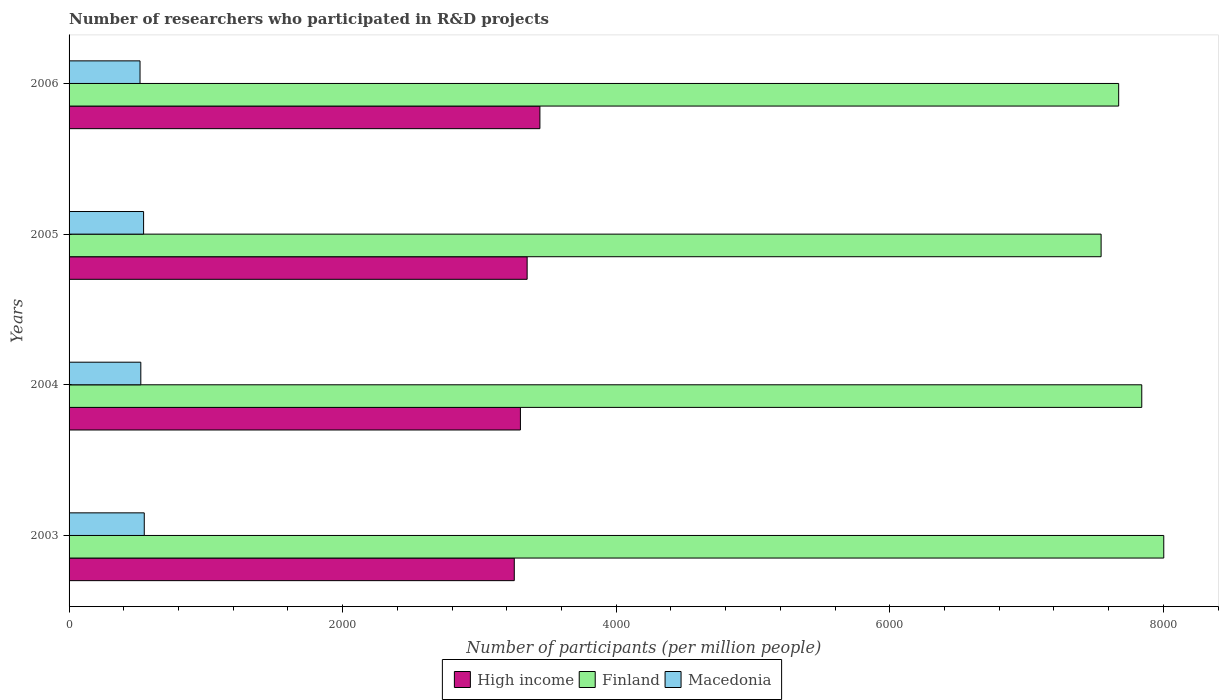How many different coloured bars are there?
Your response must be concise. 3. Are the number of bars per tick equal to the number of legend labels?
Keep it short and to the point. Yes. How many bars are there on the 4th tick from the top?
Make the answer very short. 3. How many bars are there on the 2nd tick from the bottom?
Offer a terse response. 3. What is the number of researchers who participated in R&D projects in High income in 2005?
Ensure brevity in your answer.  3348.65. Across all years, what is the maximum number of researchers who participated in R&D projects in Macedonia?
Your response must be concise. 549.66. Across all years, what is the minimum number of researchers who participated in R&D projects in High income?
Offer a very short reply. 3254.64. What is the total number of researchers who participated in R&D projects in Finland in the graph?
Your response must be concise. 3.11e+04. What is the difference between the number of researchers who participated in R&D projects in Finland in 2003 and that in 2006?
Give a very brief answer. 329.55. What is the difference between the number of researchers who participated in R&D projects in High income in 2004 and the number of researchers who participated in R&D projects in Macedonia in 2003?
Your response must be concise. 2749.95. What is the average number of researchers who participated in R&D projects in Finland per year?
Your response must be concise. 7765.53. In the year 2005, what is the difference between the number of researchers who participated in R&D projects in High income and number of researchers who participated in R&D projects in Finland?
Provide a succinct answer. -4195.99. In how many years, is the number of researchers who participated in R&D projects in Macedonia greater than 1200 ?
Keep it short and to the point. 0. What is the ratio of the number of researchers who participated in R&D projects in High income in 2005 to that in 2006?
Your answer should be compact. 0.97. Is the number of researchers who participated in R&D projects in Macedonia in 2005 less than that in 2006?
Offer a terse response. No. Is the difference between the number of researchers who participated in R&D projects in High income in 2004 and 2005 greater than the difference between the number of researchers who participated in R&D projects in Finland in 2004 and 2005?
Ensure brevity in your answer.  No. What is the difference between the highest and the second highest number of researchers who participated in R&D projects in Finland?
Ensure brevity in your answer.  160.81. What is the difference between the highest and the lowest number of researchers who participated in R&D projects in High income?
Your answer should be very brief. 187.39. Is the sum of the number of researchers who participated in R&D projects in High income in 2003 and 2005 greater than the maximum number of researchers who participated in R&D projects in Finland across all years?
Give a very brief answer. No. What does the 1st bar from the top in 2004 represents?
Offer a terse response. Macedonia. What does the 1st bar from the bottom in 2006 represents?
Make the answer very short. High income. How many bars are there?
Ensure brevity in your answer.  12. How many years are there in the graph?
Ensure brevity in your answer.  4. Does the graph contain grids?
Your answer should be very brief. No. Where does the legend appear in the graph?
Give a very brief answer. Bottom center. How many legend labels are there?
Ensure brevity in your answer.  3. What is the title of the graph?
Your answer should be compact. Number of researchers who participated in R&D projects. Does "Norway" appear as one of the legend labels in the graph?
Make the answer very short. No. What is the label or title of the X-axis?
Your answer should be compact. Number of participants (per million people). What is the Number of participants (per million people) of High income in 2003?
Your response must be concise. 3254.64. What is the Number of participants (per million people) in Finland in 2003?
Your answer should be very brief. 8002.61. What is the Number of participants (per million people) in Macedonia in 2003?
Ensure brevity in your answer.  549.66. What is the Number of participants (per million people) in High income in 2004?
Ensure brevity in your answer.  3299.61. What is the Number of participants (per million people) in Finland in 2004?
Provide a succinct answer. 7841.8. What is the Number of participants (per million people) in Macedonia in 2004?
Provide a short and direct response. 524.42. What is the Number of participants (per million people) of High income in 2005?
Your answer should be compact. 3348.65. What is the Number of participants (per million people) in Finland in 2005?
Offer a very short reply. 7544.65. What is the Number of participants (per million people) of Macedonia in 2005?
Your answer should be compact. 544.82. What is the Number of participants (per million people) of High income in 2006?
Give a very brief answer. 3442.03. What is the Number of participants (per million people) of Finland in 2006?
Offer a terse response. 7673.06. What is the Number of participants (per million people) in Macedonia in 2006?
Provide a succinct answer. 518.72. Across all years, what is the maximum Number of participants (per million people) in High income?
Make the answer very short. 3442.03. Across all years, what is the maximum Number of participants (per million people) in Finland?
Your answer should be compact. 8002.61. Across all years, what is the maximum Number of participants (per million people) in Macedonia?
Provide a short and direct response. 549.66. Across all years, what is the minimum Number of participants (per million people) in High income?
Offer a very short reply. 3254.64. Across all years, what is the minimum Number of participants (per million people) of Finland?
Your answer should be compact. 7544.65. Across all years, what is the minimum Number of participants (per million people) in Macedonia?
Give a very brief answer. 518.72. What is the total Number of participants (per million people) in High income in the graph?
Keep it short and to the point. 1.33e+04. What is the total Number of participants (per million people) of Finland in the graph?
Provide a short and direct response. 3.11e+04. What is the total Number of participants (per million people) of Macedonia in the graph?
Ensure brevity in your answer.  2137.62. What is the difference between the Number of participants (per million people) of High income in 2003 and that in 2004?
Your response must be concise. -44.97. What is the difference between the Number of participants (per million people) of Finland in 2003 and that in 2004?
Keep it short and to the point. 160.81. What is the difference between the Number of participants (per million people) of Macedonia in 2003 and that in 2004?
Ensure brevity in your answer.  25.24. What is the difference between the Number of participants (per million people) of High income in 2003 and that in 2005?
Your answer should be compact. -94.02. What is the difference between the Number of participants (per million people) of Finland in 2003 and that in 2005?
Give a very brief answer. 457.96. What is the difference between the Number of participants (per million people) of Macedonia in 2003 and that in 2005?
Offer a terse response. 4.85. What is the difference between the Number of participants (per million people) in High income in 2003 and that in 2006?
Ensure brevity in your answer.  -187.39. What is the difference between the Number of participants (per million people) in Finland in 2003 and that in 2006?
Offer a very short reply. 329.55. What is the difference between the Number of participants (per million people) of Macedonia in 2003 and that in 2006?
Ensure brevity in your answer.  30.94. What is the difference between the Number of participants (per million people) in High income in 2004 and that in 2005?
Keep it short and to the point. -49.04. What is the difference between the Number of participants (per million people) in Finland in 2004 and that in 2005?
Give a very brief answer. 297.15. What is the difference between the Number of participants (per million people) of Macedonia in 2004 and that in 2005?
Provide a succinct answer. -20.4. What is the difference between the Number of participants (per million people) of High income in 2004 and that in 2006?
Offer a very short reply. -142.42. What is the difference between the Number of participants (per million people) of Finland in 2004 and that in 2006?
Offer a terse response. 168.74. What is the difference between the Number of participants (per million people) of Macedonia in 2004 and that in 2006?
Make the answer very short. 5.7. What is the difference between the Number of participants (per million people) in High income in 2005 and that in 2006?
Your answer should be compact. -93.37. What is the difference between the Number of participants (per million people) in Finland in 2005 and that in 2006?
Keep it short and to the point. -128.41. What is the difference between the Number of participants (per million people) in Macedonia in 2005 and that in 2006?
Your response must be concise. 26.09. What is the difference between the Number of participants (per million people) in High income in 2003 and the Number of participants (per million people) in Finland in 2004?
Keep it short and to the point. -4587.16. What is the difference between the Number of participants (per million people) of High income in 2003 and the Number of participants (per million people) of Macedonia in 2004?
Provide a succinct answer. 2730.22. What is the difference between the Number of participants (per million people) in Finland in 2003 and the Number of participants (per million people) in Macedonia in 2004?
Make the answer very short. 7478.19. What is the difference between the Number of participants (per million people) of High income in 2003 and the Number of participants (per million people) of Finland in 2005?
Offer a terse response. -4290.01. What is the difference between the Number of participants (per million people) of High income in 2003 and the Number of participants (per million people) of Macedonia in 2005?
Your answer should be compact. 2709.82. What is the difference between the Number of participants (per million people) of Finland in 2003 and the Number of participants (per million people) of Macedonia in 2005?
Offer a very short reply. 7457.79. What is the difference between the Number of participants (per million people) of High income in 2003 and the Number of participants (per million people) of Finland in 2006?
Keep it short and to the point. -4418.42. What is the difference between the Number of participants (per million people) in High income in 2003 and the Number of participants (per million people) in Macedonia in 2006?
Your answer should be very brief. 2735.91. What is the difference between the Number of participants (per million people) of Finland in 2003 and the Number of participants (per million people) of Macedonia in 2006?
Your answer should be compact. 7483.88. What is the difference between the Number of participants (per million people) of High income in 2004 and the Number of participants (per million people) of Finland in 2005?
Make the answer very short. -4245.04. What is the difference between the Number of participants (per million people) in High income in 2004 and the Number of participants (per million people) in Macedonia in 2005?
Give a very brief answer. 2754.8. What is the difference between the Number of participants (per million people) of Finland in 2004 and the Number of participants (per million people) of Macedonia in 2005?
Give a very brief answer. 7296.98. What is the difference between the Number of participants (per million people) in High income in 2004 and the Number of participants (per million people) in Finland in 2006?
Your response must be concise. -4373.44. What is the difference between the Number of participants (per million people) of High income in 2004 and the Number of participants (per million people) of Macedonia in 2006?
Give a very brief answer. 2780.89. What is the difference between the Number of participants (per million people) of Finland in 2004 and the Number of participants (per million people) of Macedonia in 2006?
Give a very brief answer. 7323.07. What is the difference between the Number of participants (per million people) of High income in 2005 and the Number of participants (per million people) of Finland in 2006?
Your answer should be compact. -4324.4. What is the difference between the Number of participants (per million people) of High income in 2005 and the Number of participants (per million people) of Macedonia in 2006?
Provide a short and direct response. 2829.93. What is the difference between the Number of participants (per million people) in Finland in 2005 and the Number of participants (per million people) in Macedonia in 2006?
Provide a short and direct response. 7025.92. What is the average Number of participants (per million people) of High income per year?
Your answer should be compact. 3336.23. What is the average Number of participants (per million people) of Finland per year?
Provide a short and direct response. 7765.53. What is the average Number of participants (per million people) of Macedonia per year?
Ensure brevity in your answer.  534.41. In the year 2003, what is the difference between the Number of participants (per million people) in High income and Number of participants (per million people) in Finland?
Keep it short and to the point. -4747.97. In the year 2003, what is the difference between the Number of participants (per million people) in High income and Number of participants (per million people) in Macedonia?
Give a very brief answer. 2704.97. In the year 2003, what is the difference between the Number of participants (per million people) in Finland and Number of participants (per million people) in Macedonia?
Offer a terse response. 7452.95. In the year 2004, what is the difference between the Number of participants (per million people) of High income and Number of participants (per million people) of Finland?
Make the answer very short. -4542.19. In the year 2004, what is the difference between the Number of participants (per million people) of High income and Number of participants (per million people) of Macedonia?
Your answer should be compact. 2775.19. In the year 2004, what is the difference between the Number of participants (per million people) in Finland and Number of participants (per million people) in Macedonia?
Your answer should be very brief. 7317.38. In the year 2005, what is the difference between the Number of participants (per million people) of High income and Number of participants (per million people) of Finland?
Provide a short and direct response. -4195.99. In the year 2005, what is the difference between the Number of participants (per million people) of High income and Number of participants (per million people) of Macedonia?
Give a very brief answer. 2803.84. In the year 2005, what is the difference between the Number of participants (per million people) of Finland and Number of participants (per million people) of Macedonia?
Your answer should be compact. 6999.83. In the year 2006, what is the difference between the Number of participants (per million people) of High income and Number of participants (per million people) of Finland?
Offer a very short reply. -4231.03. In the year 2006, what is the difference between the Number of participants (per million people) in High income and Number of participants (per million people) in Macedonia?
Give a very brief answer. 2923.3. In the year 2006, what is the difference between the Number of participants (per million people) in Finland and Number of participants (per million people) in Macedonia?
Your answer should be very brief. 7154.33. What is the ratio of the Number of participants (per million people) of High income in 2003 to that in 2004?
Provide a succinct answer. 0.99. What is the ratio of the Number of participants (per million people) of Finland in 2003 to that in 2004?
Offer a terse response. 1.02. What is the ratio of the Number of participants (per million people) in Macedonia in 2003 to that in 2004?
Make the answer very short. 1.05. What is the ratio of the Number of participants (per million people) in High income in 2003 to that in 2005?
Provide a succinct answer. 0.97. What is the ratio of the Number of participants (per million people) in Finland in 2003 to that in 2005?
Your response must be concise. 1.06. What is the ratio of the Number of participants (per million people) of Macedonia in 2003 to that in 2005?
Offer a very short reply. 1.01. What is the ratio of the Number of participants (per million people) in High income in 2003 to that in 2006?
Offer a terse response. 0.95. What is the ratio of the Number of participants (per million people) in Finland in 2003 to that in 2006?
Provide a short and direct response. 1.04. What is the ratio of the Number of participants (per million people) of Macedonia in 2003 to that in 2006?
Your answer should be very brief. 1.06. What is the ratio of the Number of participants (per million people) in High income in 2004 to that in 2005?
Provide a short and direct response. 0.99. What is the ratio of the Number of participants (per million people) in Finland in 2004 to that in 2005?
Give a very brief answer. 1.04. What is the ratio of the Number of participants (per million people) of Macedonia in 2004 to that in 2005?
Keep it short and to the point. 0.96. What is the ratio of the Number of participants (per million people) of High income in 2004 to that in 2006?
Give a very brief answer. 0.96. What is the ratio of the Number of participants (per million people) of Finland in 2004 to that in 2006?
Your response must be concise. 1.02. What is the ratio of the Number of participants (per million people) in High income in 2005 to that in 2006?
Ensure brevity in your answer.  0.97. What is the ratio of the Number of participants (per million people) in Finland in 2005 to that in 2006?
Provide a succinct answer. 0.98. What is the ratio of the Number of participants (per million people) in Macedonia in 2005 to that in 2006?
Your answer should be compact. 1.05. What is the difference between the highest and the second highest Number of participants (per million people) of High income?
Provide a succinct answer. 93.37. What is the difference between the highest and the second highest Number of participants (per million people) in Finland?
Keep it short and to the point. 160.81. What is the difference between the highest and the second highest Number of participants (per million people) in Macedonia?
Your response must be concise. 4.85. What is the difference between the highest and the lowest Number of participants (per million people) of High income?
Offer a very short reply. 187.39. What is the difference between the highest and the lowest Number of participants (per million people) of Finland?
Provide a succinct answer. 457.96. What is the difference between the highest and the lowest Number of participants (per million people) in Macedonia?
Your answer should be very brief. 30.94. 